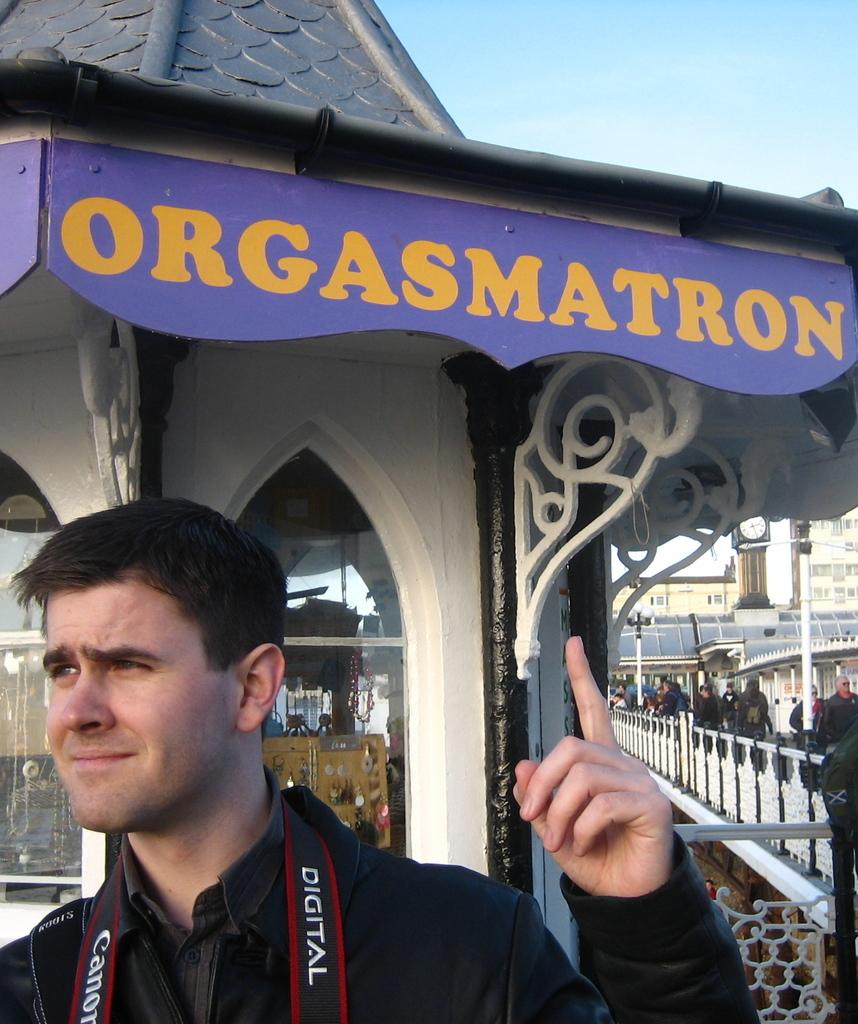Who is present in the image? There is a man in the image, along with other people. What is the man wearing? The man is wearing clothes. What can be seen in the background of the image? There is a building, a fence, a window, and the sky visible in the image. How many people are present in the image? There are other people in the image, in addition to the man. What type of cord is being used to control the trains in the image? There are no trains or cords present in the image. What drug is being administered to the people in the image? There is no drug or drug administration depicted in the image. 